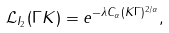<formula> <loc_0><loc_0><loc_500><loc_500>\mathcal { L } _ { I _ { 2 } } ( \Gamma K ) = e ^ { - \lambda C _ { \alpha } ( K \Gamma ) ^ { 2 / \alpha } } ,</formula> 